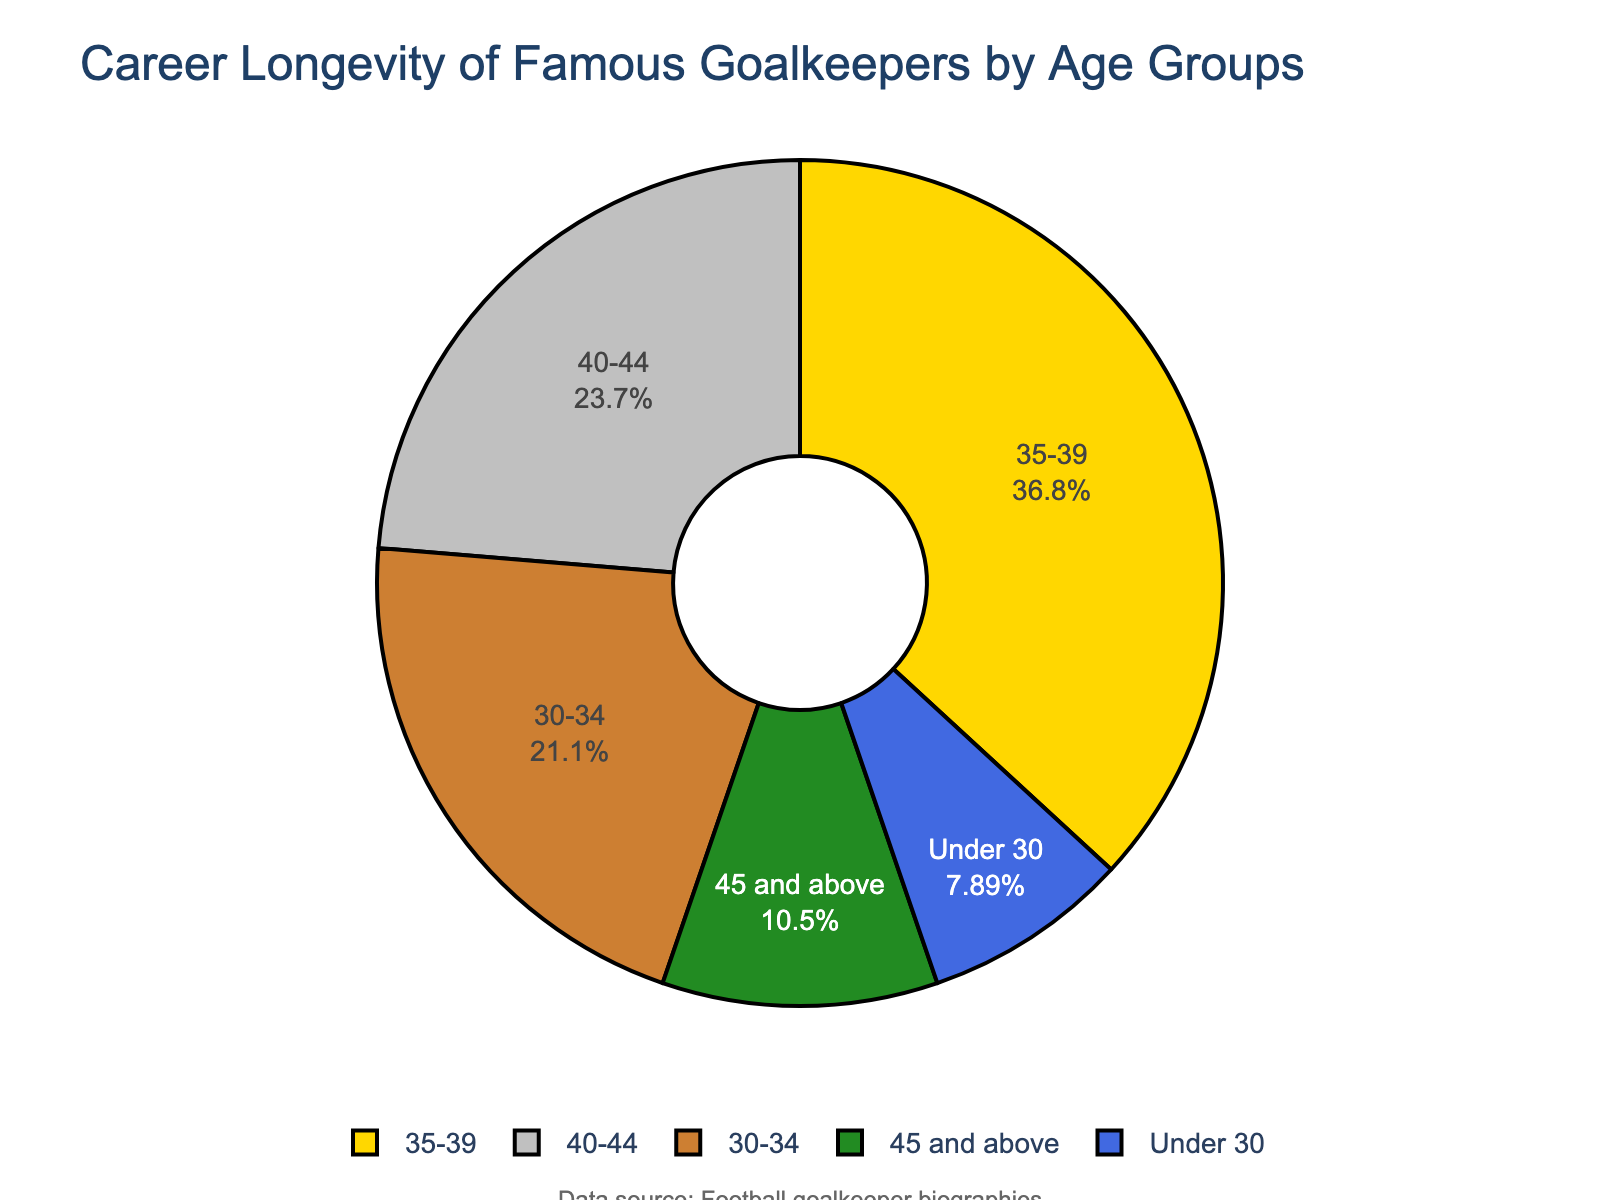What's the most common age group for famous goalkeepers? The age group with the highest number of goalkeepers will show up as the largest section of the pie chart. Looking at the chart, we see that the "35-39" age group accounts for the largest portion.
Answer: 35-39 Which age group has fewer goalkeepers, "Under 30" or "45 and above"? Comparing the segments of the pie chart for the "Under 30" and "45 and above" age groups, we see that "Under 30" has a smaller segment. The "Under 30" group has 3 goalkeepers, while the "45 and above" group has 4.
Answer: Under 30 What percentage of goalkeepers are aged 40-44? The pie chart includes labels with percentage information for each age group. The segment labeled "40-44" shows 24%.
Answer: 24% How many more goalkeepers are in the "30-34" category compared to the "Under 30"? The pie chart shows that the "30-34" category has 8 goalkeepers, while the "Under 30" category has 3. The difference is 8 - 3 = 5.
Answer: 5 What is the combined percentage of goalkeepers aged 35 and above? We need to sum the percentages for the age groups "35-39", "40-44", and "45 and above". From the pie chart, these are 38%, 24%, and 11%, respectively. Summing these gives 38% + 24% + 11% = 73%.
Answer: 73% Which age group is represented by the color green? The pie chart uses a custom color palette, and the segment colored green represents the "40-44" age group.
Answer: 40-44 How does the number of goalkeepers in the "Under 30" group compare to that in the "40-44" group? The "Under 30" group has 3 goalkeepers, while the "40-44" group has 9 goalkeepers. Thus, the "40-44" group has 6 more goalkeepers than the "Under 30" group.
Answer: 6 more If the total number of goalkeepers is 38, what is the ratio of goalkeepers aged 35-39 to those aged 45 and above? The "35-39" age group has 14 goalkeepers, and the "45 and above" age group has 4. The ratio is 14:4, which simplifies to 7:2.
Answer: 7:2 